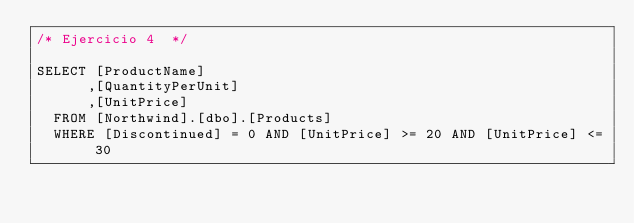<code> <loc_0><loc_0><loc_500><loc_500><_SQL_>/* Ejercicio 4  */

SELECT [ProductName]
      ,[QuantityPerUnit]
      ,[UnitPrice]
  FROM [Northwind].[dbo].[Products]
  WHERE [Discontinued] = 0 AND [UnitPrice] >= 20 AND [UnitPrice] <= 30</code> 